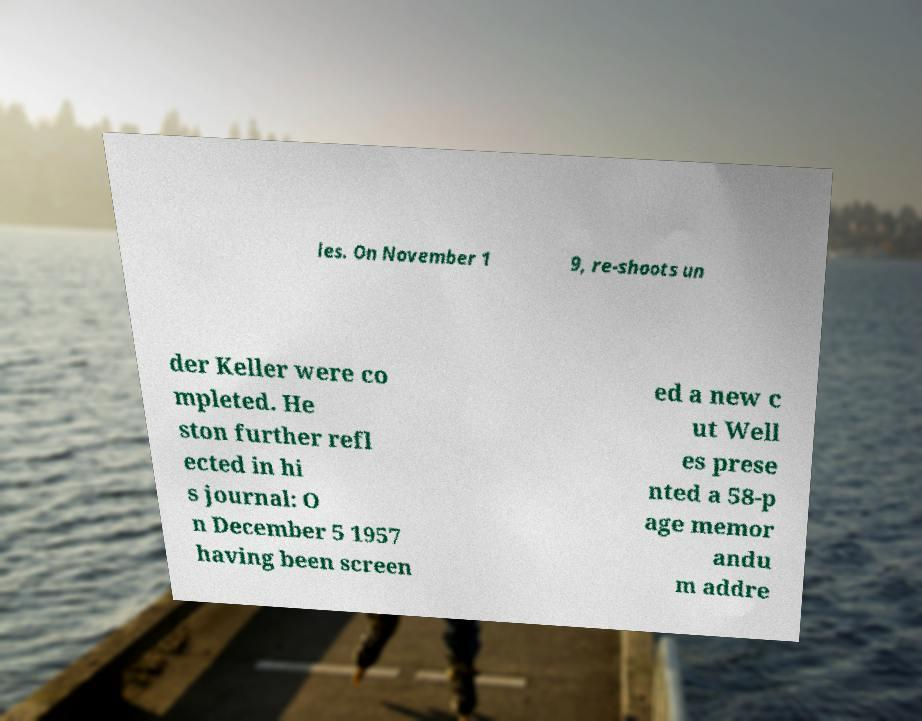Please read and relay the text visible in this image. What does it say? les. On November 1 9, re-shoots un der Keller were co mpleted. He ston further refl ected in hi s journal: O n December 5 1957 having been screen ed a new c ut Well es prese nted a 58-p age memor andu m addre 